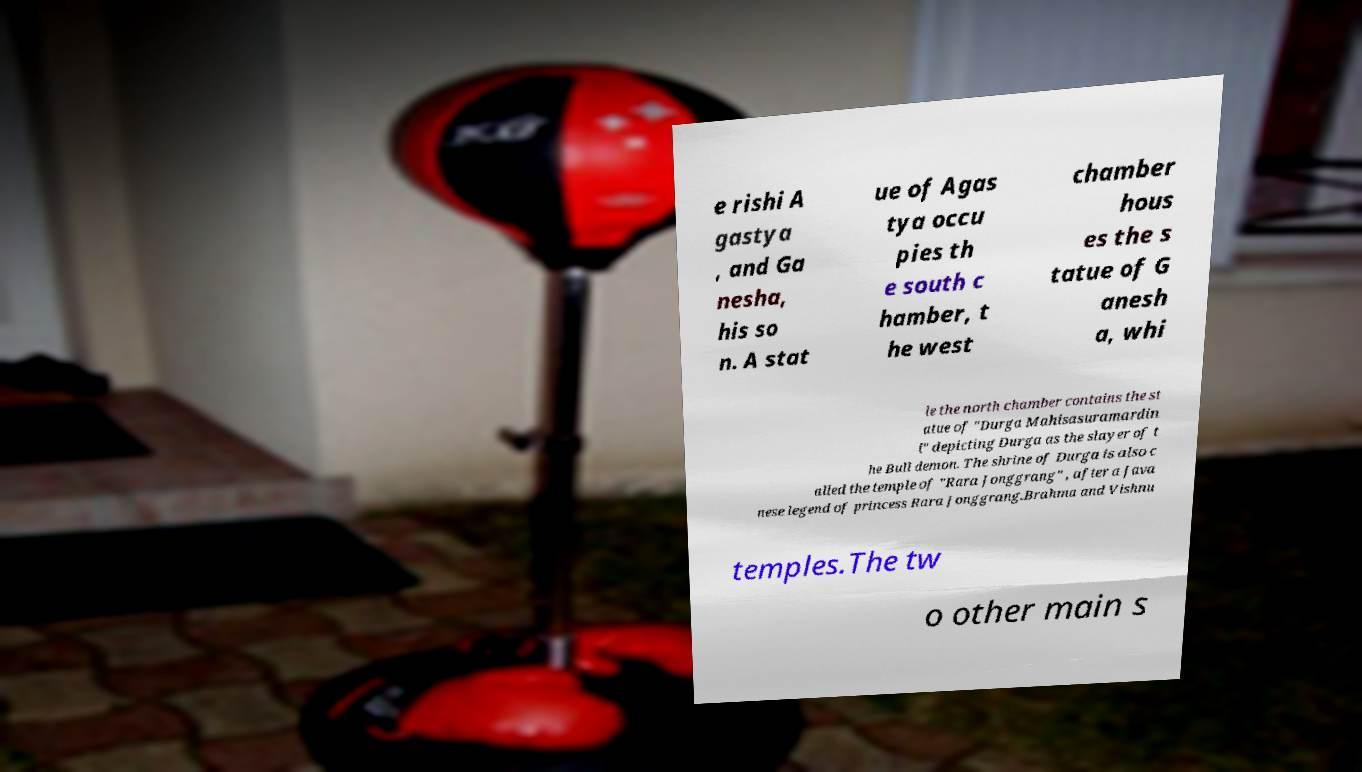There's text embedded in this image that I need extracted. Can you transcribe it verbatim? e rishi A gastya , and Ga nesha, his so n. A stat ue of Agas tya occu pies th e south c hamber, t he west chamber hous es the s tatue of G anesh a, whi le the north chamber contains the st atue of "Durga Mahisasuramardin i" depicting Durga as the slayer of t he Bull demon. The shrine of Durga is also c alled the temple of "Rara Jonggrang" , after a Java nese legend of princess Rara Jonggrang.Brahma and Vishnu temples.The tw o other main s 